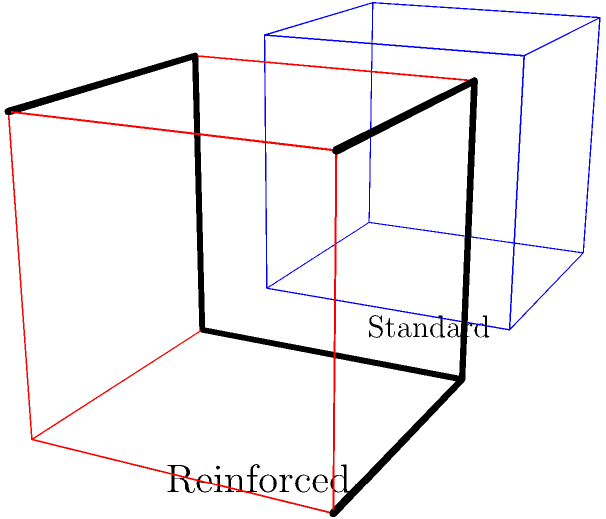As a private label manufacturer, you're evaluating two packaging designs for a fragile product: a standard box and a box with reinforced corners. The reinforced box costs 20% more to produce but is expected to reduce damage claims by 30%. If the standard box costs $2 to produce and results in an average of $1000 in damage claims per 1000 units shipped, calculate the total cost difference per 1000 units between the two designs. Which design would you recommend and why? Let's break this down step-by-step:

1. Standard box costs:
   - Production cost: $2 per box
   - For 1000 units: $2 * 1000 = $2000
   - Damage claims: $1000 per 1000 units
   - Total cost: $2000 + $1000 = $3000 per 1000 units

2. Reinforced box costs:
   - Production cost: $2 * 1.20 = $2.40 per box (20% more)
   - For 1000 units: $2.40 * 1000 = $2400
   - Damage claims: $1000 * (1 - 0.30) = $700 per 1000 units (30% reduction)
   - Total cost: $2400 + $700 = $3100 per 1000 units

3. Cost difference:
   $3100 - $3000 = $100 more per 1000 units for the reinforced box

4. Analysis:
   While the reinforced box costs $100 more per 1000 units, it offers better protection for fragile products. This could lead to:
   - Improved customer satisfaction
   - Better brand reputation
   - Potential for long-term cost savings if damage claims continue to decrease

5. Recommendation:
   Despite the slightly higher cost, the reinforced box design is recommended. The marginal cost increase ($0.10 per unit) is offset by the significant reduction in damage claims and the potential for improved customer satisfaction and brand reputation.
Answer: Reinforced box; $100 more per 1000 units, but offers better protection and potential long-term benefits. 